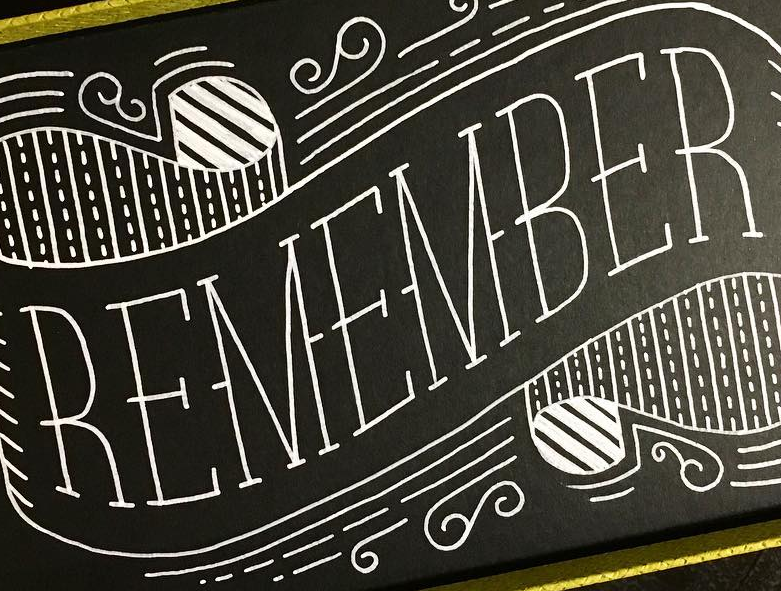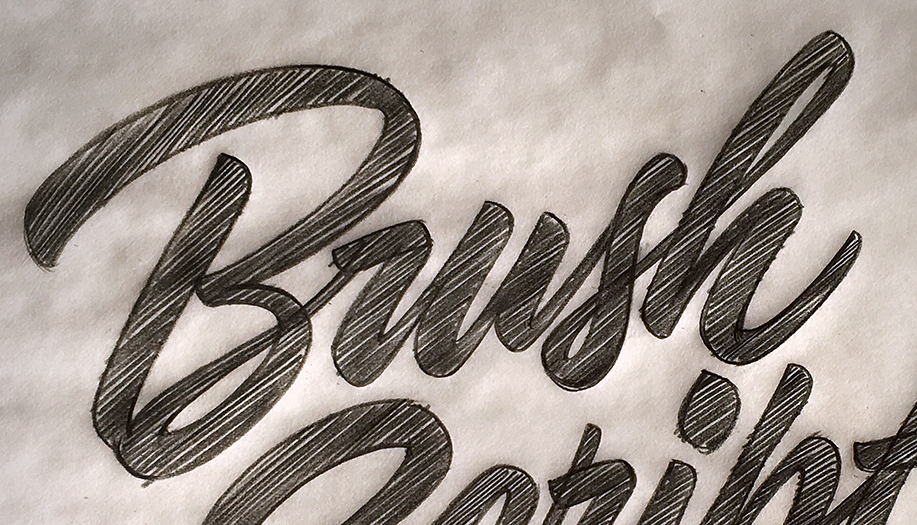What words can you see in these images in sequence, separated by a semicolon? REMEMBER; Brush 